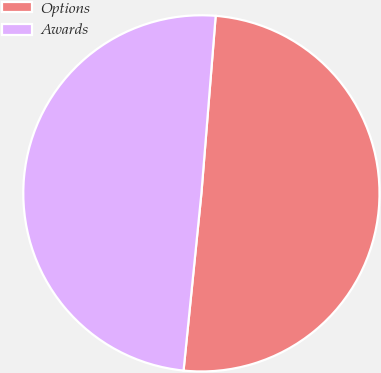<chart> <loc_0><loc_0><loc_500><loc_500><pie_chart><fcel>Options<fcel>Awards<nl><fcel>50.32%<fcel>49.68%<nl></chart> 